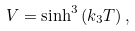<formula> <loc_0><loc_0><loc_500><loc_500>V = \sinh ^ { 3 } \, ( k _ { 3 } T ) \, ,</formula> 